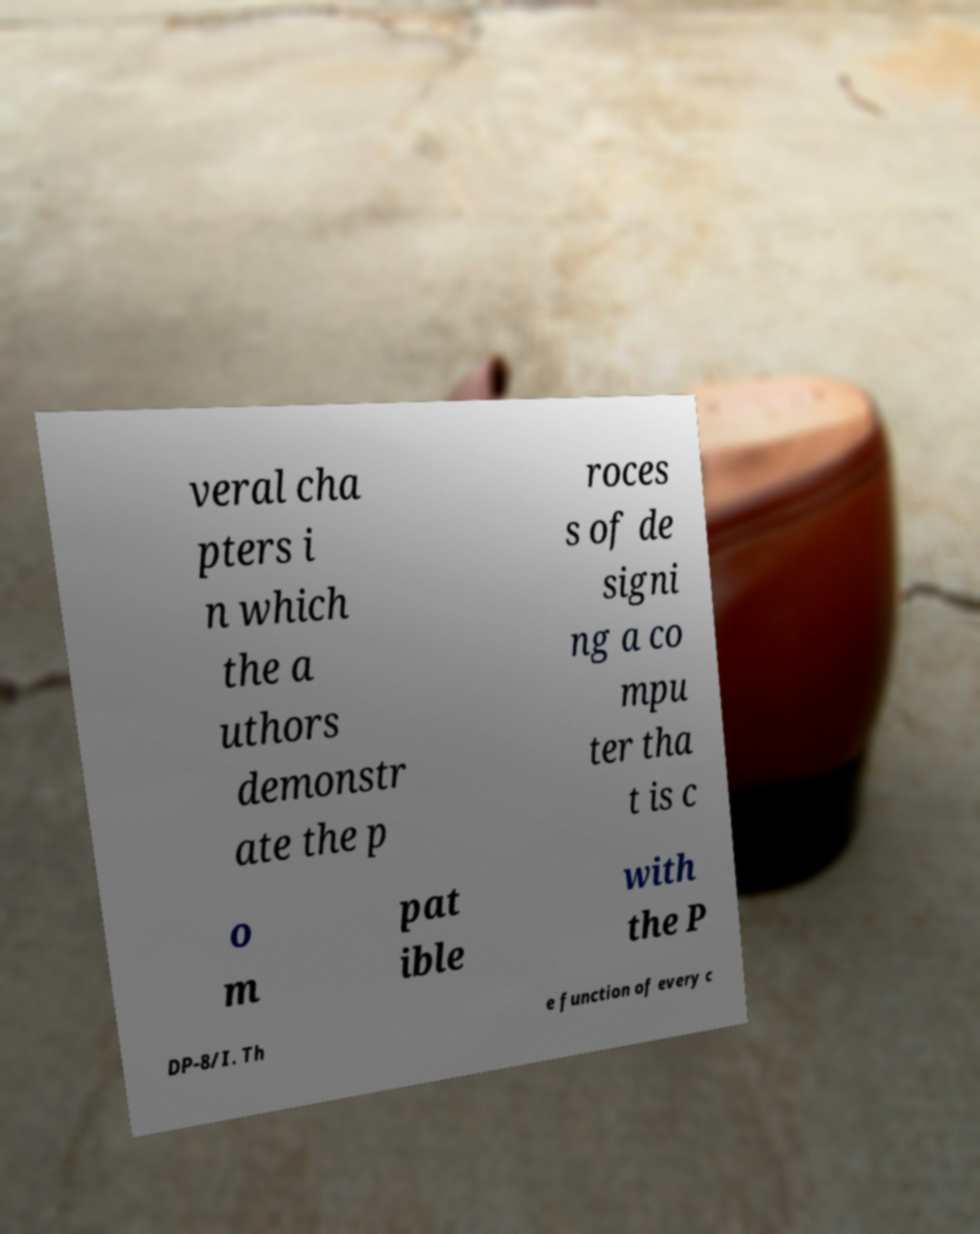Please read and relay the text visible in this image. What does it say? veral cha pters i n which the a uthors demonstr ate the p roces s of de signi ng a co mpu ter tha t is c o m pat ible with the P DP-8/I. Th e function of every c 